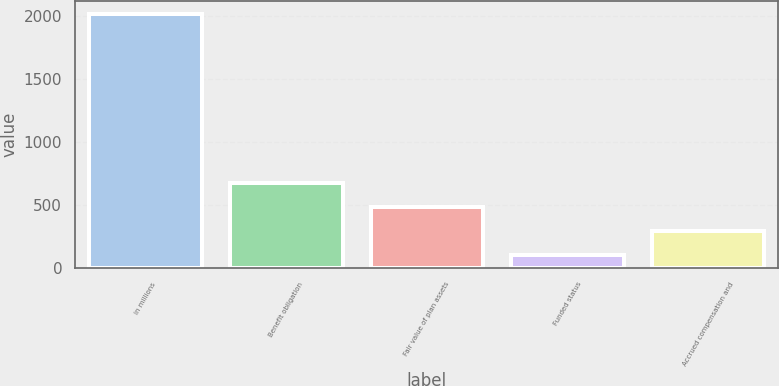<chart> <loc_0><loc_0><loc_500><loc_500><bar_chart><fcel>in millions<fcel>Benefit obligation<fcel>Fair value of plan assets<fcel>Funded status<fcel>Accrued compensation and<nl><fcel>2014<fcel>673.92<fcel>482.48<fcel>99.6<fcel>291.04<nl></chart> 